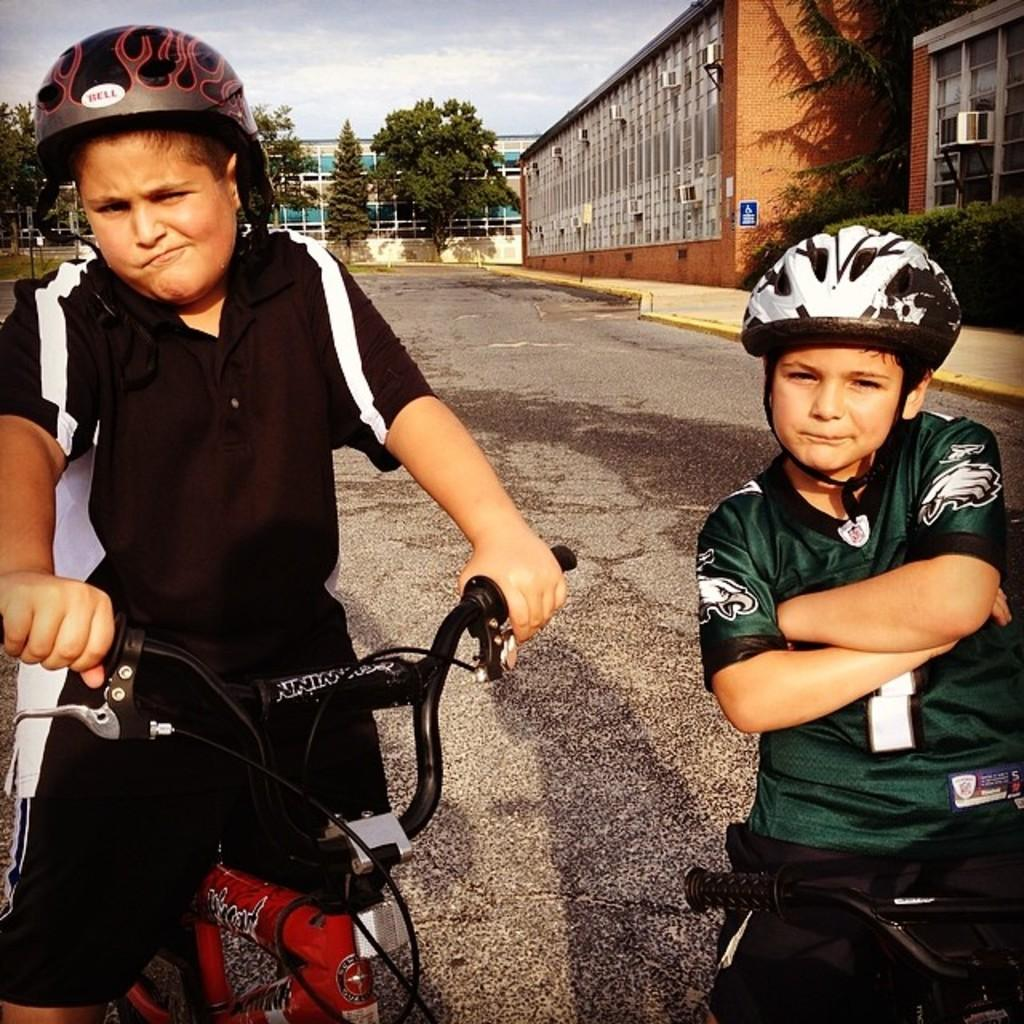How many boys are in the image? There are two boys in the image. What are the boys doing in the image? The boys are seated on a bicycle. What can be seen in the background of the image? There are shrubs, buildings, and trees in the background of the image. What type of property does the line in the image represent? There is no line present in the image, so it cannot represent any property. 